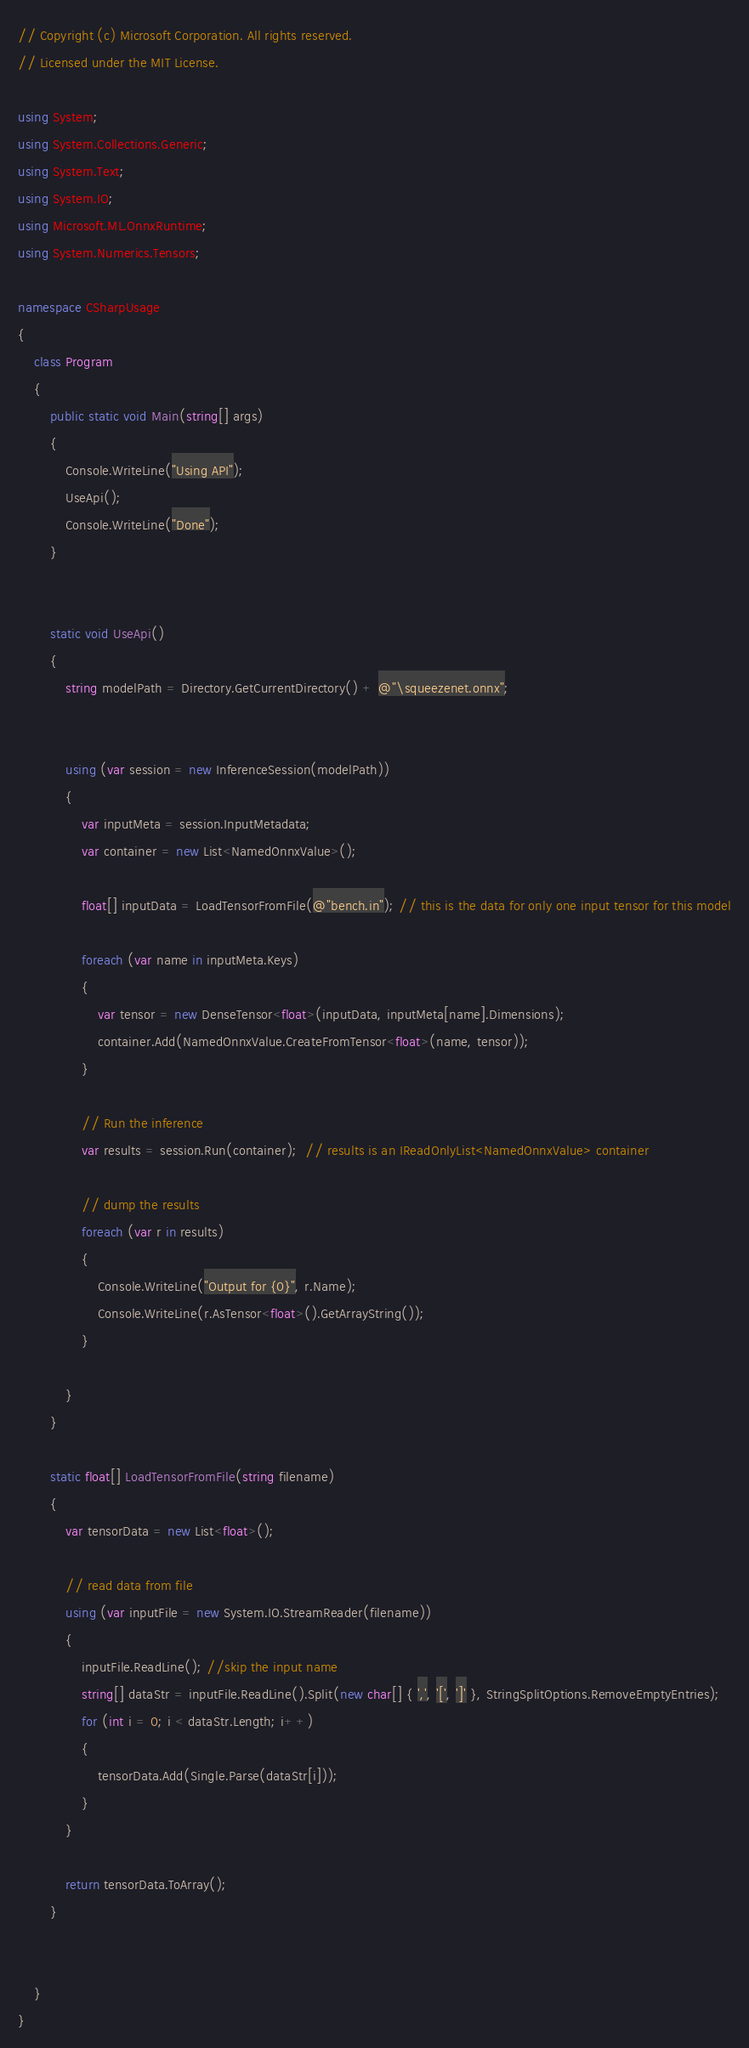Convert code to text. <code><loc_0><loc_0><loc_500><loc_500><_C#_>// Copyright (c) Microsoft Corporation. All rights reserved.
// Licensed under the MIT License.

using System;
using System.Collections.Generic;
using System.Text;
using System.IO;
using Microsoft.ML.OnnxRuntime;
using System.Numerics.Tensors;

namespace CSharpUsage
{
    class Program
    {
        public static void Main(string[] args)
        {
            Console.WriteLine("Using API");
            UseApi();
            Console.WriteLine("Done");
        }


        static void UseApi()
        {
            string modelPath = Directory.GetCurrentDirectory() + @"\squeezenet.onnx";


            using (var session = new InferenceSession(modelPath))
            {
                var inputMeta = session.InputMetadata;
                var container = new List<NamedOnnxValue>();

                float[] inputData = LoadTensorFromFile(@"bench.in"); // this is the data for only one input tensor for this model

                foreach (var name in inputMeta.Keys)
                {
                    var tensor = new DenseTensor<float>(inputData, inputMeta[name].Dimensions);
                    container.Add(NamedOnnxValue.CreateFromTensor<float>(name, tensor));
                }

                // Run the inference
                var results = session.Run(container);  // results is an IReadOnlyList<NamedOnnxValue> container

                // dump the results
                foreach (var r in results)
                {
                    Console.WriteLine("Output for {0}", r.Name);
                    Console.WriteLine(r.AsTensor<float>().GetArrayString());
                }

            }
        }

        static float[] LoadTensorFromFile(string filename)
        {
            var tensorData = new List<float>();

            // read data from file
            using (var inputFile = new System.IO.StreamReader(filename))
            {
                inputFile.ReadLine(); //skip the input name
                string[] dataStr = inputFile.ReadLine().Split(new char[] { ',', '[', ']' }, StringSplitOptions.RemoveEmptyEntries);
                for (int i = 0; i < dataStr.Length; i++)
                {
                    tensorData.Add(Single.Parse(dataStr[i]));
                }
            }

            return tensorData.ToArray();
        }


    }
}
</code> 